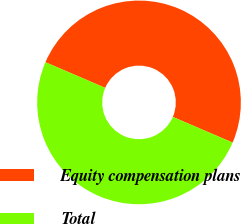Convert chart. <chart><loc_0><loc_0><loc_500><loc_500><pie_chart><fcel>Equity compensation plans<fcel>Total<nl><fcel>50.0%<fcel>50.0%<nl></chart> 